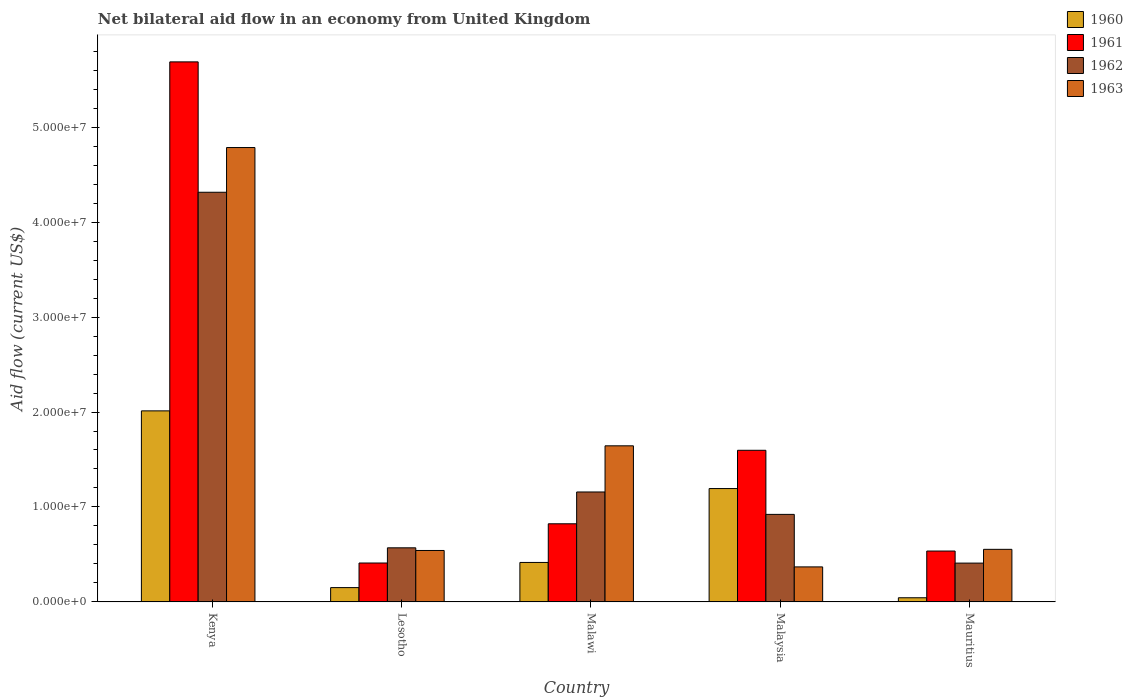How many different coloured bars are there?
Offer a terse response. 4. How many bars are there on the 5th tick from the left?
Give a very brief answer. 4. What is the label of the 1st group of bars from the left?
Your answer should be very brief. Kenya. In how many cases, is the number of bars for a given country not equal to the number of legend labels?
Keep it short and to the point. 0. What is the net bilateral aid flow in 1961 in Mauritius?
Give a very brief answer. 5.36e+06. Across all countries, what is the maximum net bilateral aid flow in 1962?
Keep it short and to the point. 4.31e+07. Across all countries, what is the minimum net bilateral aid flow in 1962?
Your answer should be compact. 4.09e+06. In which country was the net bilateral aid flow in 1961 maximum?
Offer a terse response. Kenya. In which country was the net bilateral aid flow in 1960 minimum?
Ensure brevity in your answer.  Mauritius. What is the total net bilateral aid flow in 1963 in the graph?
Make the answer very short. 7.89e+07. What is the difference between the net bilateral aid flow in 1961 in Kenya and that in Malaysia?
Keep it short and to the point. 4.09e+07. What is the difference between the net bilateral aid flow in 1963 in Malawi and the net bilateral aid flow in 1962 in Malaysia?
Make the answer very short. 7.22e+06. What is the average net bilateral aid flow in 1960 per country?
Ensure brevity in your answer.  7.63e+06. What is the difference between the net bilateral aid flow of/in 1963 and net bilateral aid flow of/in 1961 in Lesotho?
Ensure brevity in your answer.  1.32e+06. In how many countries, is the net bilateral aid flow in 1962 greater than 10000000 US$?
Your answer should be compact. 2. What is the ratio of the net bilateral aid flow in 1962 in Malaysia to that in Mauritius?
Make the answer very short. 2.25. Is the net bilateral aid flow in 1962 in Lesotho less than that in Malaysia?
Your response must be concise. Yes. What is the difference between the highest and the second highest net bilateral aid flow in 1962?
Offer a terse response. 3.16e+07. What is the difference between the highest and the lowest net bilateral aid flow in 1961?
Make the answer very short. 5.28e+07. Is it the case that in every country, the sum of the net bilateral aid flow in 1961 and net bilateral aid flow in 1962 is greater than the sum of net bilateral aid flow in 1960 and net bilateral aid flow in 1963?
Provide a short and direct response. No. How many bars are there?
Give a very brief answer. 20. Are all the bars in the graph horizontal?
Provide a succinct answer. No. What is the difference between two consecutive major ticks on the Y-axis?
Keep it short and to the point. 1.00e+07. Does the graph contain grids?
Your response must be concise. No. How many legend labels are there?
Your response must be concise. 4. How are the legend labels stacked?
Make the answer very short. Vertical. What is the title of the graph?
Keep it short and to the point. Net bilateral aid flow in an economy from United Kingdom. What is the label or title of the X-axis?
Ensure brevity in your answer.  Country. What is the Aid flow (current US$) in 1960 in Kenya?
Ensure brevity in your answer.  2.01e+07. What is the Aid flow (current US$) in 1961 in Kenya?
Provide a succinct answer. 5.69e+07. What is the Aid flow (current US$) of 1962 in Kenya?
Provide a succinct answer. 4.31e+07. What is the Aid flow (current US$) in 1963 in Kenya?
Provide a succinct answer. 4.78e+07. What is the Aid flow (current US$) of 1960 in Lesotho?
Offer a very short reply. 1.51e+06. What is the Aid flow (current US$) of 1961 in Lesotho?
Provide a succinct answer. 4.10e+06. What is the Aid flow (current US$) in 1962 in Lesotho?
Make the answer very short. 5.70e+06. What is the Aid flow (current US$) in 1963 in Lesotho?
Provide a short and direct response. 5.42e+06. What is the Aid flow (current US$) in 1960 in Malawi?
Provide a short and direct response. 4.16e+06. What is the Aid flow (current US$) in 1961 in Malawi?
Keep it short and to the point. 8.23e+06. What is the Aid flow (current US$) of 1962 in Malawi?
Give a very brief answer. 1.16e+07. What is the Aid flow (current US$) in 1963 in Malawi?
Make the answer very short. 1.64e+07. What is the Aid flow (current US$) in 1960 in Malaysia?
Provide a short and direct response. 1.19e+07. What is the Aid flow (current US$) in 1961 in Malaysia?
Provide a short and direct response. 1.60e+07. What is the Aid flow (current US$) in 1962 in Malaysia?
Offer a very short reply. 9.22e+06. What is the Aid flow (current US$) in 1963 in Malaysia?
Give a very brief answer. 3.69e+06. What is the Aid flow (current US$) of 1961 in Mauritius?
Give a very brief answer. 5.36e+06. What is the Aid flow (current US$) of 1962 in Mauritius?
Your answer should be compact. 4.09e+06. What is the Aid flow (current US$) of 1963 in Mauritius?
Ensure brevity in your answer.  5.54e+06. Across all countries, what is the maximum Aid flow (current US$) in 1960?
Provide a short and direct response. 2.01e+07. Across all countries, what is the maximum Aid flow (current US$) of 1961?
Offer a very short reply. 5.69e+07. Across all countries, what is the maximum Aid flow (current US$) of 1962?
Provide a succinct answer. 4.31e+07. Across all countries, what is the maximum Aid flow (current US$) of 1963?
Provide a short and direct response. 4.78e+07. Across all countries, what is the minimum Aid flow (current US$) in 1961?
Offer a very short reply. 4.10e+06. Across all countries, what is the minimum Aid flow (current US$) in 1962?
Your response must be concise. 4.09e+06. Across all countries, what is the minimum Aid flow (current US$) of 1963?
Make the answer very short. 3.69e+06. What is the total Aid flow (current US$) in 1960 in the graph?
Offer a very short reply. 3.82e+07. What is the total Aid flow (current US$) in 1961 in the graph?
Your answer should be compact. 9.05e+07. What is the total Aid flow (current US$) of 1962 in the graph?
Your answer should be very brief. 7.37e+07. What is the total Aid flow (current US$) in 1963 in the graph?
Your answer should be compact. 7.89e+07. What is the difference between the Aid flow (current US$) of 1960 in Kenya and that in Lesotho?
Provide a succinct answer. 1.86e+07. What is the difference between the Aid flow (current US$) of 1961 in Kenya and that in Lesotho?
Your answer should be compact. 5.28e+07. What is the difference between the Aid flow (current US$) of 1962 in Kenya and that in Lesotho?
Ensure brevity in your answer.  3.74e+07. What is the difference between the Aid flow (current US$) of 1963 in Kenya and that in Lesotho?
Keep it short and to the point. 4.24e+07. What is the difference between the Aid flow (current US$) of 1960 in Kenya and that in Malawi?
Your response must be concise. 1.60e+07. What is the difference between the Aid flow (current US$) of 1961 in Kenya and that in Malawi?
Make the answer very short. 4.86e+07. What is the difference between the Aid flow (current US$) of 1962 in Kenya and that in Malawi?
Your response must be concise. 3.16e+07. What is the difference between the Aid flow (current US$) in 1963 in Kenya and that in Malawi?
Keep it short and to the point. 3.14e+07. What is the difference between the Aid flow (current US$) of 1960 in Kenya and that in Malaysia?
Offer a terse response. 8.18e+06. What is the difference between the Aid flow (current US$) in 1961 in Kenya and that in Malaysia?
Provide a short and direct response. 4.09e+07. What is the difference between the Aid flow (current US$) of 1962 in Kenya and that in Malaysia?
Make the answer very short. 3.39e+07. What is the difference between the Aid flow (current US$) of 1963 in Kenya and that in Malaysia?
Give a very brief answer. 4.42e+07. What is the difference between the Aid flow (current US$) in 1960 in Kenya and that in Mauritius?
Make the answer very short. 1.97e+07. What is the difference between the Aid flow (current US$) in 1961 in Kenya and that in Mauritius?
Offer a very short reply. 5.15e+07. What is the difference between the Aid flow (current US$) of 1962 in Kenya and that in Mauritius?
Keep it short and to the point. 3.90e+07. What is the difference between the Aid flow (current US$) in 1963 in Kenya and that in Mauritius?
Provide a short and direct response. 4.23e+07. What is the difference between the Aid flow (current US$) of 1960 in Lesotho and that in Malawi?
Keep it short and to the point. -2.65e+06. What is the difference between the Aid flow (current US$) of 1961 in Lesotho and that in Malawi?
Keep it short and to the point. -4.13e+06. What is the difference between the Aid flow (current US$) in 1962 in Lesotho and that in Malawi?
Make the answer very short. -5.88e+06. What is the difference between the Aid flow (current US$) of 1963 in Lesotho and that in Malawi?
Provide a short and direct response. -1.10e+07. What is the difference between the Aid flow (current US$) of 1960 in Lesotho and that in Malaysia?
Keep it short and to the point. -1.04e+07. What is the difference between the Aid flow (current US$) of 1961 in Lesotho and that in Malaysia?
Make the answer very short. -1.19e+07. What is the difference between the Aid flow (current US$) in 1962 in Lesotho and that in Malaysia?
Ensure brevity in your answer.  -3.52e+06. What is the difference between the Aid flow (current US$) in 1963 in Lesotho and that in Malaysia?
Give a very brief answer. 1.73e+06. What is the difference between the Aid flow (current US$) of 1960 in Lesotho and that in Mauritius?
Ensure brevity in your answer.  1.07e+06. What is the difference between the Aid flow (current US$) of 1961 in Lesotho and that in Mauritius?
Make the answer very short. -1.26e+06. What is the difference between the Aid flow (current US$) in 1962 in Lesotho and that in Mauritius?
Ensure brevity in your answer.  1.61e+06. What is the difference between the Aid flow (current US$) in 1960 in Malawi and that in Malaysia?
Offer a terse response. -7.78e+06. What is the difference between the Aid flow (current US$) in 1961 in Malawi and that in Malaysia?
Offer a very short reply. -7.74e+06. What is the difference between the Aid flow (current US$) in 1962 in Malawi and that in Malaysia?
Offer a very short reply. 2.36e+06. What is the difference between the Aid flow (current US$) of 1963 in Malawi and that in Malaysia?
Ensure brevity in your answer.  1.28e+07. What is the difference between the Aid flow (current US$) of 1960 in Malawi and that in Mauritius?
Your answer should be very brief. 3.72e+06. What is the difference between the Aid flow (current US$) in 1961 in Malawi and that in Mauritius?
Your response must be concise. 2.87e+06. What is the difference between the Aid flow (current US$) of 1962 in Malawi and that in Mauritius?
Your answer should be compact. 7.49e+06. What is the difference between the Aid flow (current US$) in 1963 in Malawi and that in Mauritius?
Offer a terse response. 1.09e+07. What is the difference between the Aid flow (current US$) of 1960 in Malaysia and that in Mauritius?
Offer a terse response. 1.15e+07. What is the difference between the Aid flow (current US$) in 1961 in Malaysia and that in Mauritius?
Offer a very short reply. 1.06e+07. What is the difference between the Aid flow (current US$) in 1962 in Malaysia and that in Mauritius?
Give a very brief answer. 5.13e+06. What is the difference between the Aid flow (current US$) of 1963 in Malaysia and that in Mauritius?
Your answer should be compact. -1.85e+06. What is the difference between the Aid flow (current US$) in 1960 in Kenya and the Aid flow (current US$) in 1961 in Lesotho?
Offer a terse response. 1.60e+07. What is the difference between the Aid flow (current US$) of 1960 in Kenya and the Aid flow (current US$) of 1962 in Lesotho?
Give a very brief answer. 1.44e+07. What is the difference between the Aid flow (current US$) in 1960 in Kenya and the Aid flow (current US$) in 1963 in Lesotho?
Your answer should be compact. 1.47e+07. What is the difference between the Aid flow (current US$) in 1961 in Kenya and the Aid flow (current US$) in 1962 in Lesotho?
Offer a very short reply. 5.12e+07. What is the difference between the Aid flow (current US$) of 1961 in Kenya and the Aid flow (current US$) of 1963 in Lesotho?
Provide a succinct answer. 5.14e+07. What is the difference between the Aid flow (current US$) of 1962 in Kenya and the Aid flow (current US$) of 1963 in Lesotho?
Offer a very short reply. 3.77e+07. What is the difference between the Aid flow (current US$) in 1960 in Kenya and the Aid flow (current US$) in 1961 in Malawi?
Keep it short and to the point. 1.19e+07. What is the difference between the Aid flow (current US$) of 1960 in Kenya and the Aid flow (current US$) of 1962 in Malawi?
Make the answer very short. 8.54e+06. What is the difference between the Aid flow (current US$) in 1960 in Kenya and the Aid flow (current US$) in 1963 in Malawi?
Offer a terse response. 3.68e+06. What is the difference between the Aid flow (current US$) of 1961 in Kenya and the Aid flow (current US$) of 1962 in Malawi?
Make the answer very short. 4.53e+07. What is the difference between the Aid flow (current US$) of 1961 in Kenya and the Aid flow (current US$) of 1963 in Malawi?
Keep it short and to the point. 4.04e+07. What is the difference between the Aid flow (current US$) of 1962 in Kenya and the Aid flow (current US$) of 1963 in Malawi?
Give a very brief answer. 2.67e+07. What is the difference between the Aid flow (current US$) in 1960 in Kenya and the Aid flow (current US$) in 1961 in Malaysia?
Make the answer very short. 4.15e+06. What is the difference between the Aid flow (current US$) of 1960 in Kenya and the Aid flow (current US$) of 1962 in Malaysia?
Your answer should be compact. 1.09e+07. What is the difference between the Aid flow (current US$) in 1960 in Kenya and the Aid flow (current US$) in 1963 in Malaysia?
Provide a succinct answer. 1.64e+07. What is the difference between the Aid flow (current US$) in 1961 in Kenya and the Aid flow (current US$) in 1962 in Malaysia?
Give a very brief answer. 4.76e+07. What is the difference between the Aid flow (current US$) of 1961 in Kenya and the Aid flow (current US$) of 1963 in Malaysia?
Your response must be concise. 5.32e+07. What is the difference between the Aid flow (current US$) in 1962 in Kenya and the Aid flow (current US$) in 1963 in Malaysia?
Give a very brief answer. 3.94e+07. What is the difference between the Aid flow (current US$) of 1960 in Kenya and the Aid flow (current US$) of 1961 in Mauritius?
Give a very brief answer. 1.48e+07. What is the difference between the Aid flow (current US$) of 1960 in Kenya and the Aid flow (current US$) of 1962 in Mauritius?
Provide a succinct answer. 1.60e+07. What is the difference between the Aid flow (current US$) in 1960 in Kenya and the Aid flow (current US$) in 1963 in Mauritius?
Make the answer very short. 1.46e+07. What is the difference between the Aid flow (current US$) in 1961 in Kenya and the Aid flow (current US$) in 1962 in Mauritius?
Ensure brevity in your answer.  5.28e+07. What is the difference between the Aid flow (current US$) in 1961 in Kenya and the Aid flow (current US$) in 1963 in Mauritius?
Ensure brevity in your answer.  5.13e+07. What is the difference between the Aid flow (current US$) in 1962 in Kenya and the Aid flow (current US$) in 1963 in Mauritius?
Your response must be concise. 3.76e+07. What is the difference between the Aid flow (current US$) of 1960 in Lesotho and the Aid flow (current US$) of 1961 in Malawi?
Your answer should be very brief. -6.72e+06. What is the difference between the Aid flow (current US$) in 1960 in Lesotho and the Aid flow (current US$) in 1962 in Malawi?
Offer a terse response. -1.01e+07. What is the difference between the Aid flow (current US$) in 1960 in Lesotho and the Aid flow (current US$) in 1963 in Malawi?
Provide a short and direct response. -1.49e+07. What is the difference between the Aid flow (current US$) in 1961 in Lesotho and the Aid flow (current US$) in 1962 in Malawi?
Your answer should be very brief. -7.48e+06. What is the difference between the Aid flow (current US$) in 1961 in Lesotho and the Aid flow (current US$) in 1963 in Malawi?
Your answer should be very brief. -1.23e+07. What is the difference between the Aid flow (current US$) in 1962 in Lesotho and the Aid flow (current US$) in 1963 in Malawi?
Provide a succinct answer. -1.07e+07. What is the difference between the Aid flow (current US$) of 1960 in Lesotho and the Aid flow (current US$) of 1961 in Malaysia?
Your answer should be very brief. -1.45e+07. What is the difference between the Aid flow (current US$) in 1960 in Lesotho and the Aid flow (current US$) in 1962 in Malaysia?
Ensure brevity in your answer.  -7.71e+06. What is the difference between the Aid flow (current US$) of 1960 in Lesotho and the Aid flow (current US$) of 1963 in Malaysia?
Ensure brevity in your answer.  -2.18e+06. What is the difference between the Aid flow (current US$) of 1961 in Lesotho and the Aid flow (current US$) of 1962 in Malaysia?
Keep it short and to the point. -5.12e+06. What is the difference between the Aid flow (current US$) in 1961 in Lesotho and the Aid flow (current US$) in 1963 in Malaysia?
Offer a very short reply. 4.10e+05. What is the difference between the Aid flow (current US$) of 1962 in Lesotho and the Aid flow (current US$) of 1963 in Malaysia?
Give a very brief answer. 2.01e+06. What is the difference between the Aid flow (current US$) in 1960 in Lesotho and the Aid flow (current US$) in 1961 in Mauritius?
Provide a succinct answer. -3.85e+06. What is the difference between the Aid flow (current US$) in 1960 in Lesotho and the Aid flow (current US$) in 1962 in Mauritius?
Keep it short and to the point. -2.58e+06. What is the difference between the Aid flow (current US$) of 1960 in Lesotho and the Aid flow (current US$) of 1963 in Mauritius?
Provide a succinct answer. -4.03e+06. What is the difference between the Aid flow (current US$) of 1961 in Lesotho and the Aid flow (current US$) of 1962 in Mauritius?
Provide a succinct answer. 10000. What is the difference between the Aid flow (current US$) in 1961 in Lesotho and the Aid flow (current US$) in 1963 in Mauritius?
Provide a short and direct response. -1.44e+06. What is the difference between the Aid flow (current US$) in 1962 in Lesotho and the Aid flow (current US$) in 1963 in Mauritius?
Your response must be concise. 1.60e+05. What is the difference between the Aid flow (current US$) in 1960 in Malawi and the Aid flow (current US$) in 1961 in Malaysia?
Offer a terse response. -1.18e+07. What is the difference between the Aid flow (current US$) in 1960 in Malawi and the Aid flow (current US$) in 1962 in Malaysia?
Your response must be concise. -5.06e+06. What is the difference between the Aid flow (current US$) of 1961 in Malawi and the Aid flow (current US$) of 1962 in Malaysia?
Give a very brief answer. -9.90e+05. What is the difference between the Aid flow (current US$) in 1961 in Malawi and the Aid flow (current US$) in 1963 in Malaysia?
Give a very brief answer. 4.54e+06. What is the difference between the Aid flow (current US$) of 1962 in Malawi and the Aid flow (current US$) of 1963 in Malaysia?
Keep it short and to the point. 7.89e+06. What is the difference between the Aid flow (current US$) in 1960 in Malawi and the Aid flow (current US$) in 1961 in Mauritius?
Your answer should be compact. -1.20e+06. What is the difference between the Aid flow (current US$) in 1960 in Malawi and the Aid flow (current US$) in 1962 in Mauritius?
Keep it short and to the point. 7.00e+04. What is the difference between the Aid flow (current US$) of 1960 in Malawi and the Aid flow (current US$) of 1963 in Mauritius?
Ensure brevity in your answer.  -1.38e+06. What is the difference between the Aid flow (current US$) of 1961 in Malawi and the Aid flow (current US$) of 1962 in Mauritius?
Your response must be concise. 4.14e+06. What is the difference between the Aid flow (current US$) of 1961 in Malawi and the Aid flow (current US$) of 1963 in Mauritius?
Your response must be concise. 2.69e+06. What is the difference between the Aid flow (current US$) of 1962 in Malawi and the Aid flow (current US$) of 1963 in Mauritius?
Provide a short and direct response. 6.04e+06. What is the difference between the Aid flow (current US$) in 1960 in Malaysia and the Aid flow (current US$) in 1961 in Mauritius?
Offer a very short reply. 6.58e+06. What is the difference between the Aid flow (current US$) of 1960 in Malaysia and the Aid flow (current US$) of 1962 in Mauritius?
Give a very brief answer. 7.85e+06. What is the difference between the Aid flow (current US$) in 1960 in Malaysia and the Aid flow (current US$) in 1963 in Mauritius?
Keep it short and to the point. 6.40e+06. What is the difference between the Aid flow (current US$) in 1961 in Malaysia and the Aid flow (current US$) in 1962 in Mauritius?
Offer a terse response. 1.19e+07. What is the difference between the Aid flow (current US$) in 1961 in Malaysia and the Aid flow (current US$) in 1963 in Mauritius?
Give a very brief answer. 1.04e+07. What is the difference between the Aid flow (current US$) in 1962 in Malaysia and the Aid flow (current US$) in 1963 in Mauritius?
Your response must be concise. 3.68e+06. What is the average Aid flow (current US$) of 1960 per country?
Offer a terse response. 7.63e+06. What is the average Aid flow (current US$) of 1961 per country?
Your answer should be very brief. 1.81e+07. What is the average Aid flow (current US$) in 1962 per country?
Your answer should be compact. 1.47e+07. What is the average Aid flow (current US$) of 1963 per country?
Offer a terse response. 1.58e+07. What is the difference between the Aid flow (current US$) of 1960 and Aid flow (current US$) of 1961 in Kenya?
Ensure brevity in your answer.  -3.68e+07. What is the difference between the Aid flow (current US$) in 1960 and Aid flow (current US$) in 1962 in Kenya?
Provide a short and direct response. -2.30e+07. What is the difference between the Aid flow (current US$) of 1960 and Aid flow (current US$) of 1963 in Kenya?
Ensure brevity in your answer.  -2.77e+07. What is the difference between the Aid flow (current US$) in 1961 and Aid flow (current US$) in 1962 in Kenya?
Give a very brief answer. 1.37e+07. What is the difference between the Aid flow (current US$) in 1961 and Aid flow (current US$) in 1963 in Kenya?
Provide a succinct answer. 9.02e+06. What is the difference between the Aid flow (current US$) of 1962 and Aid flow (current US$) of 1963 in Kenya?
Keep it short and to the point. -4.71e+06. What is the difference between the Aid flow (current US$) in 1960 and Aid flow (current US$) in 1961 in Lesotho?
Ensure brevity in your answer.  -2.59e+06. What is the difference between the Aid flow (current US$) of 1960 and Aid flow (current US$) of 1962 in Lesotho?
Offer a very short reply. -4.19e+06. What is the difference between the Aid flow (current US$) in 1960 and Aid flow (current US$) in 1963 in Lesotho?
Your answer should be compact. -3.91e+06. What is the difference between the Aid flow (current US$) in 1961 and Aid flow (current US$) in 1962 in Lesotho?
Give a very brief answer. -1.60e+06. What is the difference between the Aid flow (current US$) of 1961 and Aid flow (current US$) of 1963 in Lesotho?
Offer a terse response. -1.32e+06. What is the difference between the Aid flow (current US$) in 1962 and Aid flow (current US$) in 1963 in Lesotho?
Provide a short and direct response. 2.80e+05. What is the difference between the Aid flow (current US$) of 1960 and Aid flow (current US$) of 1961 in Malawi?
Ensure brevity in your answer.  -4.07e+06. What is the difference between the Aid flow (current US$) in 1960 and Aid flow (current US$) in 1962 in Malawi?
Provide a succinct answer. -7.42e+06. What is the difference between the Aid flow (current US$) of 1960 and Aid flow (current US$) of 1963 in Malawi?
Provide a short and direct response. -1.23e+07. What is the difference between the Aid flow (current US$) in 1961 and Aid flow (current US$) in 1962 in Malawi?
Make the answer very short. -3.35e+06. What is the difference between the Aid flow (current US$) of 1961 and Aid flow (current US$) of 1963 in Malawi?
Make the answer very short. -8.21e+06. What is the difference between the Aid flow (current US$) of 1962 and Aid flow (current US$) of 1963 in Malawi?
Give a very brief answer. -4.86e+06. What is the difference between the Aid flow (current US$) in 1960 and Aid flow (current US$) in 1961 in Malaysia?
Provide a succinct answer. -4.03e+06. What is the difference between the Aid flow (current US$) of 1960 and Aid flow (current US$) of 1962 in Malaysia?
Offer a very short reply. 2.72e+06. What is the difference between the Aid flow (current US$) of 1960 and Aid flow (current US$) of 1963 in Malaysia?
Offer a terse response. 8.25e+06. What is the difference between the Aid flow (current US$) of 1961 and Aid flow (current US$) of 1962 in Malaysia?
Offer a terse response. 6.75e+06. What is the difference between the Aid flow (current US$) of 1961 and Aid flow (current US$) of 1963 in Malaysia?
Provide a succinct answer. 1.23e+07. What is the difference between the Aid flow (current US$) in 1962 and Aid flow (current US$) in 1963 in Malaysia?
Give a very brief answer. 5.53e+06. What is the difference between the Aid flow (current US$) in 1960 and Aid flow (current US$) in 1961 in Mauritius?
Ensure brevity in your answer.  -4.92e+06. What is the difference between the Aid flow (current US$) of 1960 and Aid flow (current US$) of 1962 in Mauritius?
Your answer should be very brief. -3.65e+06. What is the difference between the Aid flow (current US$) of 1960 and Aid flow (current US$) of 1963 in Mauritius?
Your response must be concise. -5.10e+06. What is the difference between the Aid flow (current US$) of 1961 and Aid flow (current US$) of 1962 in Mauritius?
Provide a succinct answer. 1.27e+06. What is the difference between the Aid flow (current US$) in 1961 and Aid flow (current US$) in 1963 in Mauritius?
Ensure brevity in your answer.  -1.80e+05. What is the difference between the Aid flow (current US$) of 1962 and Aid flow (current US$) of 1963 in Mauritius?
Ensure brevity in your answer.  -1.45e+06. What is the ratio of the Aid flow (current US$) in 1960 in Kenya to that in Lesotho?
Provide a succinct answer. 13.32. What is the ratio of the Aid flow (current US$) of 1961 in Kenya to that in Lesotho?
Your response must be concise. 13.87. What is the ratio of the Aid flow (current US$) in 1962 in Kenya to that in Lesotho?
Provide a short and direct response. 7.57. What is the ratio of the Aid flow (current US$) of 1963 in Kenya to that in Lesotho?
Offer a very short reply. 8.83. What is the ratio of the Aid flow (current US$) of 1960 in Kenya to that in Malawi?
Keep it short and to the point. 4.84. What is the ratio of the Aid flow (current US$) of 1961 in Kenya to that in Malawi?
Your answer should be compact. 6.91. What is the ratio of the Aid flow (current US$) of 1962 in Kenya to that in Malawi?
Provide a short and direct response. 3.73. What is the ratio of the Aid flow (current US$) in 1963 in Kenya to that in Malawi?
Your response must be concise. 2.91. What is the ratio of the Aid flow (current US$) of 1960 in Kenya to that in Malaysia?
Give a very brief answer. 1.69. What is the ratio of the Aid flow (current US$) of 1961 in Kenya to that in Malaysia?
Ensure brevity in your answer.  3.56. What is the ratio of the Aid flow (current US$) in 1962 in Kenya to that in Malaysia?
Your answer should be compact. 4.68. What is the ratio of the Aid flow (current US$) in 1963 in Kenya to that in Malaysia?
Keep it short and to the point. 12.97. What is the ratio of the Aid flow (current US$) of 1960 in Kenya to that in Mauritius?
Make the answer very short. 45.73. What is the ratio of the Aid flow (current US$) of 1961 in Kenya to that in Mauritius?
Your answer should be compact. 10.61. What is the ratio of the Aid flow (current US$) of 1962 in Kenya to that in Mauritius?
Give a very brief answer. 10.55. What is the ratio of the Aid flow (current US$) of 1963 in Kenya to that in Mauritius?
Give a very brief answer. 8.64. What is the ratio of the Aid flow (current US$) of 1960 in Lesotho to that in Malawi?
Offer a terse response. 0.36. What is the ratio of the Aid flow (current US$) in 1961 in Lesotho to that in Malawi?
Offer a very short reply. 0.5. What is the ratio of the Aid flow (current US$) in 1962 in Lesotho to that in Malawi?
Ensure brevity in your answer.  0.49. What is the ratio of the Aid flow (current US$) in 1963 in Lesotho to that in Malawi?
Give a very brief answer. 0.33. What is the ratio of the Aid flow (current US$) of 1960 in Lesotho to that in Malaysia?
Make the answer very short. 0.13. What is the ratio of the Aid flow (current US$) in 1961 in Lesotho to that in Malaysia?
Make the answer very short. 0.26. What is the ratio of the Aid flow (current US$) in 1962 in Lesotho to that in Malaysia?
Your response must be concise. 0.62. What is the ratio of the Aid flow (current US$) of 1963 in Lesotho to that in Malaysia?
Your answer should be very brief. 1.47. What is the ratio of the Aid flow (current US$) in 1960 in Lesotho to that in Mauritius?
Provide a succinct answer. 3.43. What is the ratio of the Aid flow (current US$) of 1961 in Lesotho to that in Mauritius?
Ensure brevity in your answer.  0.76. What is the ratio of the Aid flow (current US$) in 1962 in Lesotho to that in Mauritius?
Give a very brief answer. 1.39. What is the ratio of the Aid flow (current US$) of 1963 in Lesotho to that in Mauritius?
Offer a very short reply. 0.98. What is the ratio of the Aid flow (current US$) in 1960 in Malawi to that in Malaysia?
Your answer should be very brief. 0.35. What is the ratio of the Aid flow (current US$) of 1961 in Malawi to that in Malaysia?
Keep it short and to the point. 0.52. What is the ratio of the Aid flow (current US$) of 1962 in Malawi to that in Malaysia?
Keep it short and to the point. 1.26. What is the ratio of the Aid flow (current US$) of 1963 in Malawi to that in Malaysia?
Offer a terse response. 4.46. What is the ratio of the Aid flow (current US$) of 1960 in Malawi to that in Mauritius?
Offer a terse response. 9.45. What is the ratio of the Aid flow (current US$) in 1961 in Malawi to that in Mauritius?
Your answer should be very brief. 1.54. What is the ratio of the Aid flow (current US$) in 1962 in Malawi to that in Mauritius?
Provide a succinct answer. 2.83. What is the ratio of the Aid flow (current US$) in 1963 in Malawi to that in Mauritius?
Your answer should be compact. 2.97. What is the ratio of the Aid flow (current US$) of 1960 in Malaysia to that in Mauritius?
Make the answer very short. 27.14. What is the ratio of the Aid flow (current US$) of 1961 in Malaysia to that in Mauritius?
Your answer should be compact. 2.98. What is the ratio of the Aid flow (current US$) in 1962 in Malaysia to that in Mauritius?
Give a very brief answer. 2.25. What is the ratio of the Aid flow (current US$) of 1963 in Malaysia to that in Mauritius?
Your answer should be compact. 0.67. What is the difference between the highest and the second highest Aid flow (current US$) in 1960?
Provide a succinct answer. 8.18e+06. What is the difference between the highest and the second highest Aid flow (current US$) of 1961?
Provide a short and direct response. 4.09e+07. What is the difference between the highest and the second highest Aid flow (current US$) of 1962?
Your answer should be very brief. 3.16e+07. What is the difference between the highest and the second highest Aid flow (current US$) of 1963?
Make the answer very short. 3.14e+07. What is the difference between the highest and the lowest Aid flow (current US$) of 1960?
Your answer should be very brief. 1.97e+07. What is the difference between the highest and the lowest Aid flow (current US$) of 1961?
Your response must be concise. 5.28e+07. What is the difference between the highest and the lowest Aid flow (current US$) of 1962?
Make the answer very short. 3.90e+07. What is the difference between the highest and the lowest Aid flow (current US$) in 1963?
Keep it short and to the point. 4.42e+07. 